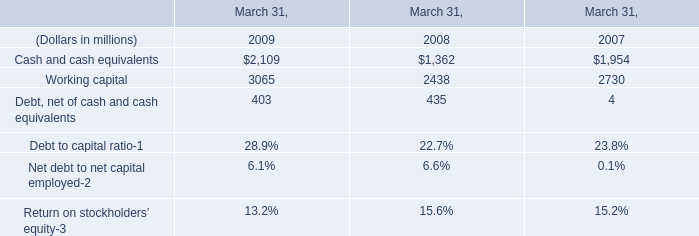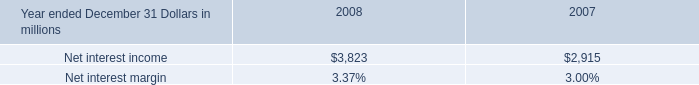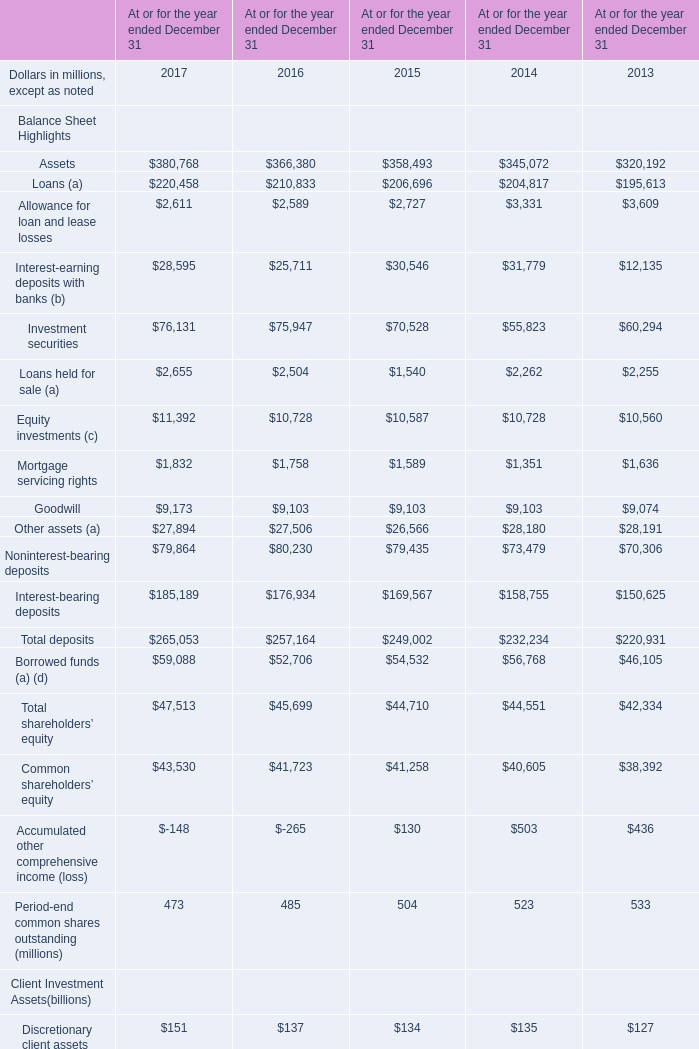What was the total amount of the Total deposits for Balance Sheet Highlights in the years where Assets greater than 350000 for Balance Sheet Highlights? (in million) 
Computations: ((265053 + 257164) + 249002)
Answer: 771219.0. 